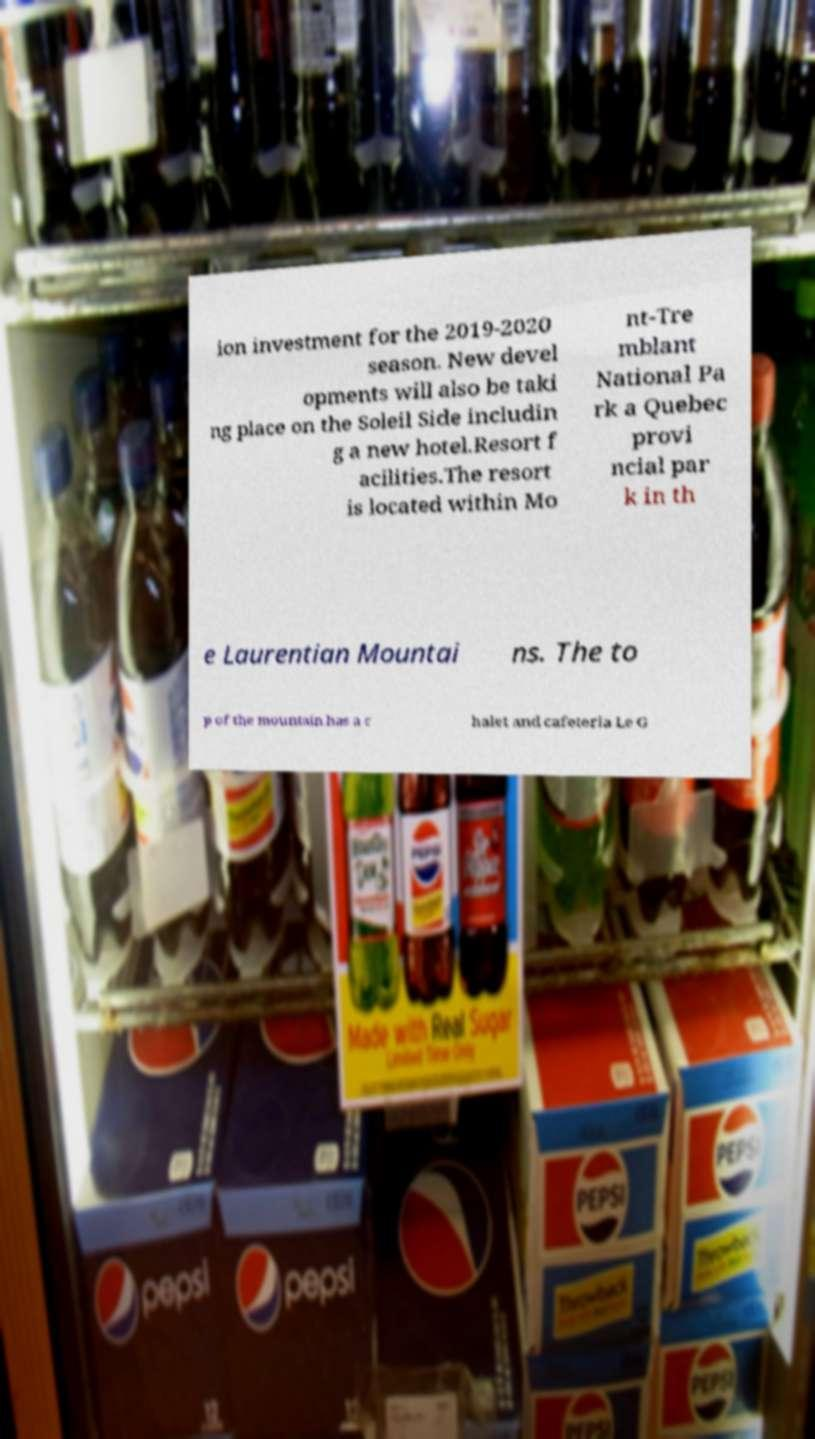Can you read and provide the text displayed in the image?This photo seems to have some interesting text. Can you extract and type it out for me? ion investment for the 2019-2020 season. New devel opments will also be taki ng place on the Soleil Side includin g a new hotel.Resort f acilities.The resort is located within Mo nt-Tre mblant National Pa rk a Quebec provi ncial par k in th e Laurentian Mountai ns. The to p of the mountain has a c halet and cafeteria Le G 